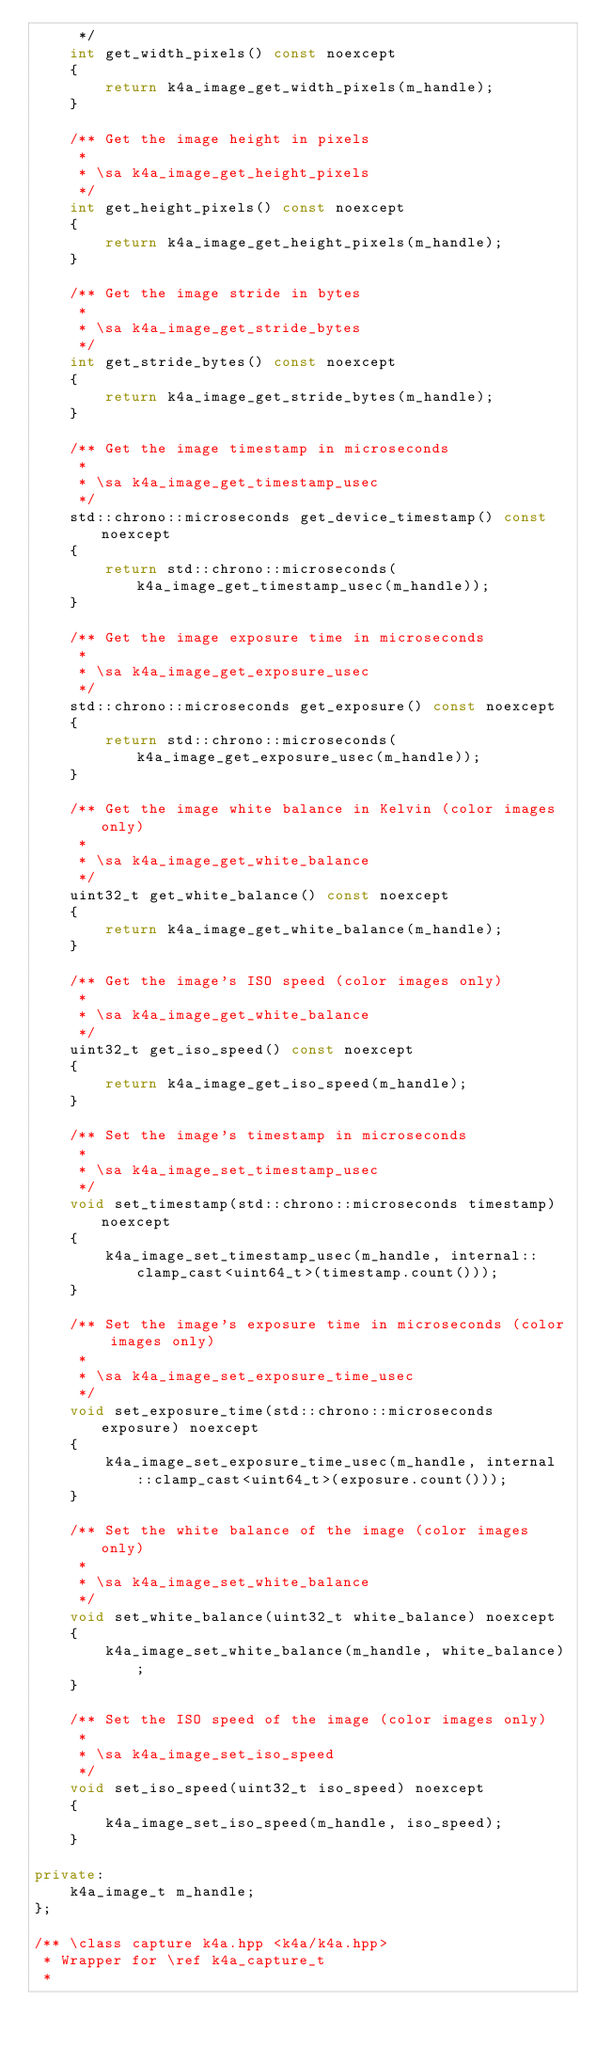<code> <loc_0><loc_0><loc_500><loc_500><_C++_>     */
    int get_width_pixels() const noexcept
    {
        return k4a_image_get_width_pixels(m_handle);
    }

    /** Get the image height in pixels
     *
     * \sa k4a_image_get_height_pixels
     */
    int get_height_pixels() const noexcept
    {
        return k4a_image_get_height_pixels(m_handle);
    }

    /** Get the image stride in bytes
     *
     * \sa k4a_image_get_stride_bytes
     */
    int get_stride_bytes() const noexcept
    {
        return k4a_image_get_stride_bytes(m_handle);
    }

    /** Get the image timestamp in microseconds
     *
     * \sa k4a_image_get_timestamp_usec
     */
    std::chrono::microseconds get_device_timestamp() const noexcept
    {
        return std::chrono::microseconds(k4a_image_get_timestamp_usec(m_handle));
    }

    /** Get the image exposure time in microseconds
     *
     * \sa k4a_image_get_exposure_usec
     */
    std::chrono::microseconds get_exposure() const noexcept
    {
        return std::chrono::microseconds(k4a_image_get_exposure_usec(m_handle));
    }

    /** Get the image white balance in Kelvin (color images only)
     *
     * \sa k4a_image_get_white_balance
     */
    uint32_t get_white_balance() const noexcept
    {
        return k4a_image_get_white_balance(m_handle);
    }

    /** Get the image's ISO speed (color images only)
     *
     * \sa k4a_image_get_white_balance
     */
    uint32_t get_iso_speed() const noexcept
    {
        return k4a_image_get_iso_speed(m_handle);
    }

    /** Set the image's timestamp in microseconds
     *
     * \sa k4a_image_set_timestamp_usec
     */
    void set_timestamp(std::chrono::microseconds timestamp) noexcept
    {
        k4a_image_set_timestamp_usec(m_handle, internal::clamp_cast<uint64_t>(timestamp.count()));
    }

    /** Set the image's exposure time in microseconds (color images only)
     *
     * \sa k4a_image_set_exposure_time_usec
     */
    void set_exposure_time(std::chrono::microseconds exposure) noexcept
    {
        k4a_image_set_exposure_time_usec(m_handle, internal::clamp_cast<uint64_t>(exposure.count()));
    }

    /** Set the white balance of the image (color images only)
     *
     * \sa k4a_image_set_white_balance
     */
    void set_white_balance(uint32_t white_balance) noexcept
    {
        k4a_image_set_white_balance(m_handle, white_balance);
    }

    /** Set the ISO speed of the image (color images only)
     *
     * \sa k4a_image_set_iso_speed
     */
    void set_iso_speed(uint32_t iso_speed) noexcept
    {
        k4a_image_set_iso_speed(m_handle, iso_speed);
    }

private:
    k4a_image_t m_handle;
};

/** \class capture k4a.hpp <k4a/k4a.hpp>
 * Wrapper for \ref k4a_capture_t
 *</code> 